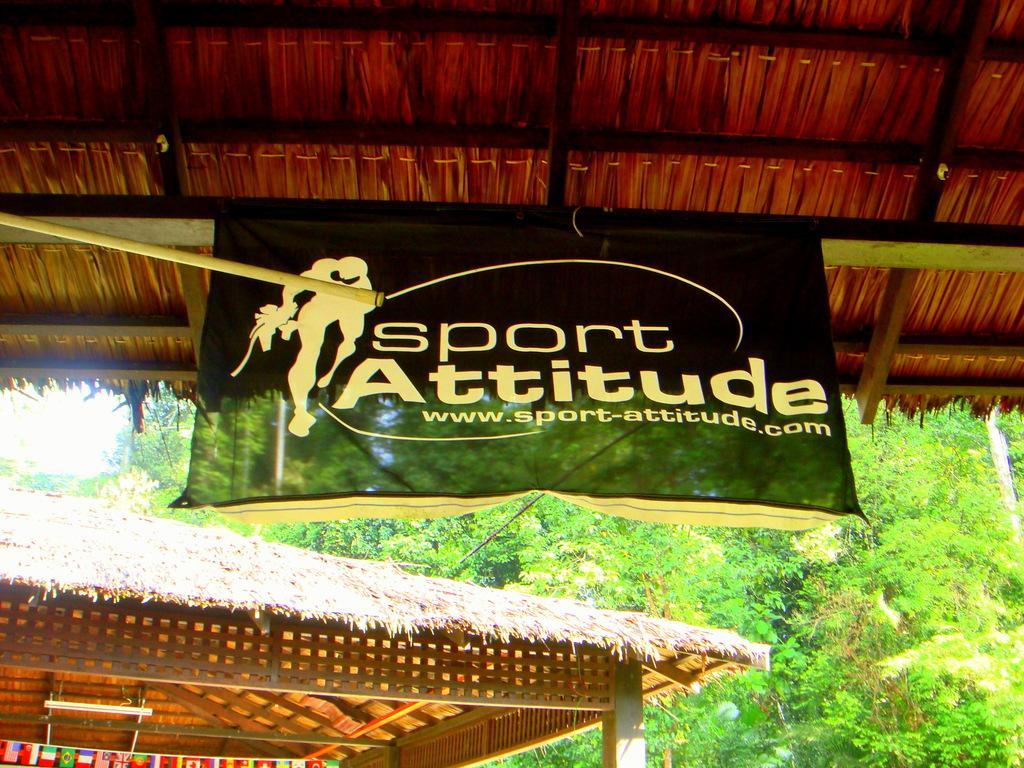In one or two sentences, can you explain what this image depicts? This image consists of huts. In the front, we can see a banner tied to the roof. In the background, there are trees. 